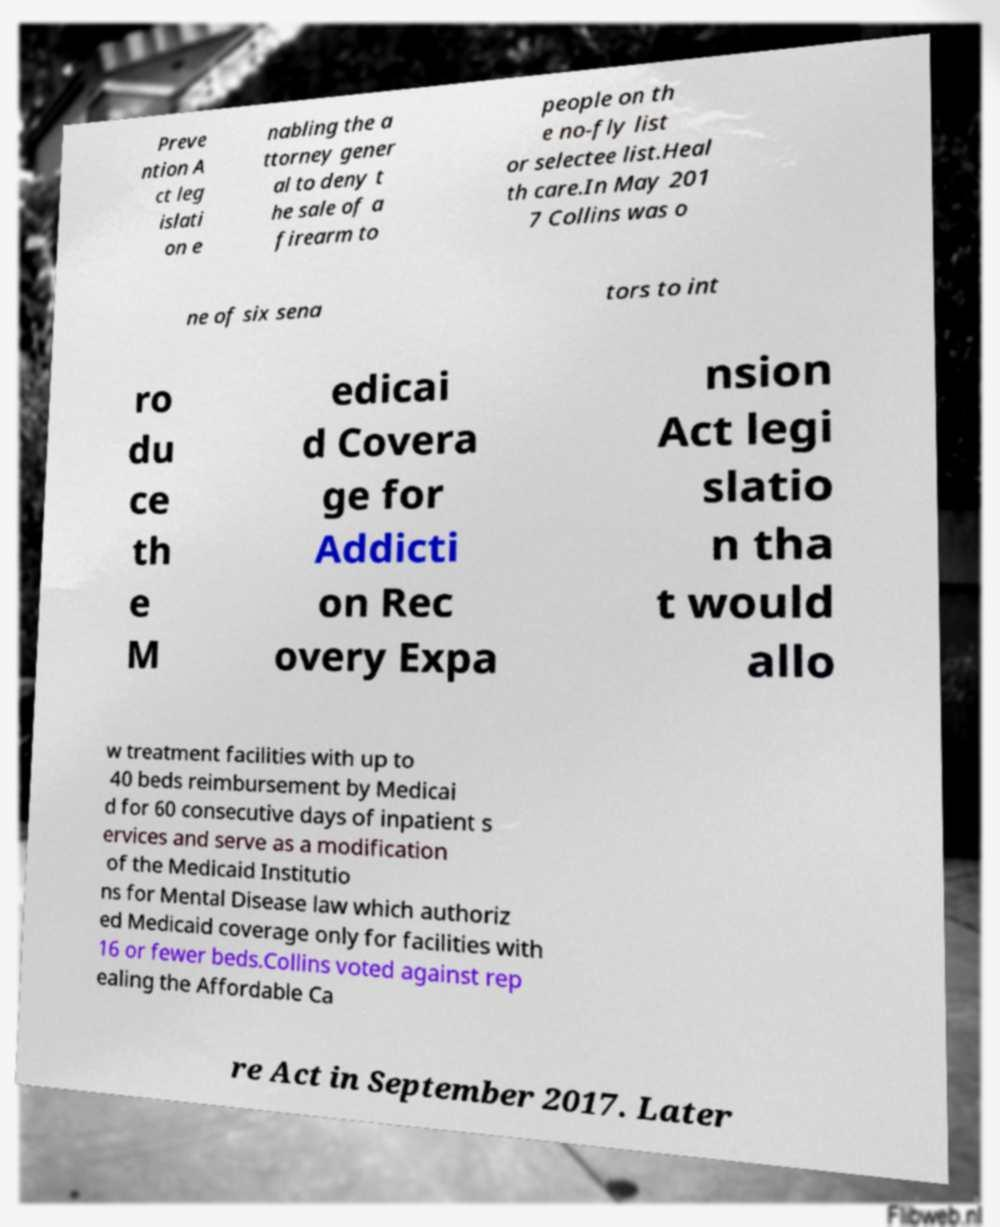Could you extract and type out the text from this image? Preve ntion A ct leg islati on e nabling the a ttorney gener al to deny t he sale of a firearm to people on th e no-fly list or selectee list.Heal th care.In May 201 7 Collins was o ne of six sena tors to int ro du ce th e M edicai d Covera ge for Addicti on Rec overy Expa nsion Act legi slatio n tha t would allo w treatment facilities with up to 40 beds reimbursement by Medicai d for 60 consecutive days of inpatient s ervices and serve as a modification of the Medicaid Institutio ns for Mental Disease law which authoriz ed Medicaid coverage only for facilities with 16 or fewer beds.Collins voted against rep ealing the Affordable Ca re Act in September 2017. Later 